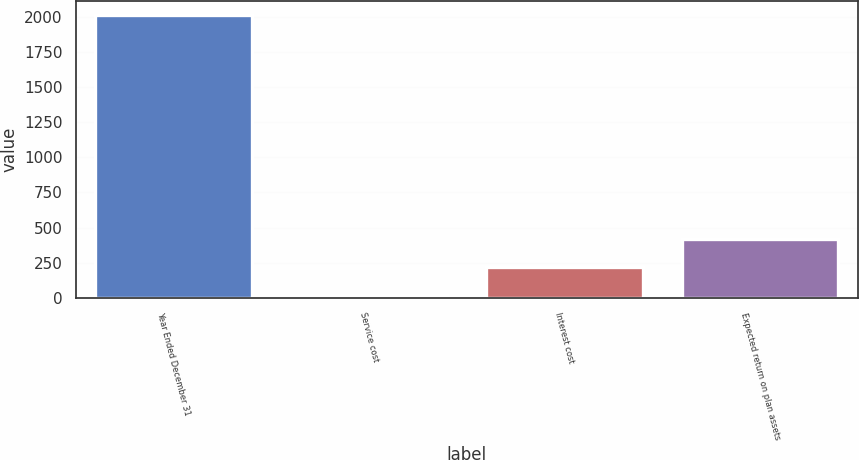Convert chart. <chart><loc_0><loc_0><loc_500><loc_500><bar_chart><fcel>Year Ended December 31<fcel>Service cost<fcel>Interest cost<fcel>Expected return on plan assets<nl><fcel>2011<fcel>24<fcel>222.7<fcel>421.4<nl></chart> 